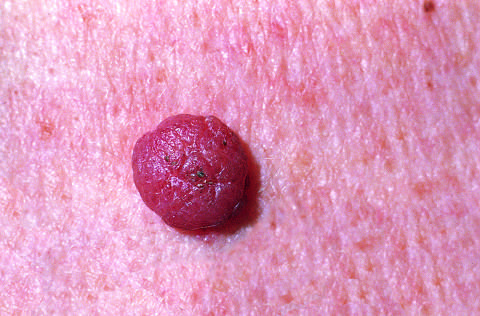re undifferentiated pleomorphic sarcoma showing anaplastic relatively small, symmetric, and uniformly pigmented?
Answer the question using a single word or phrase. No 